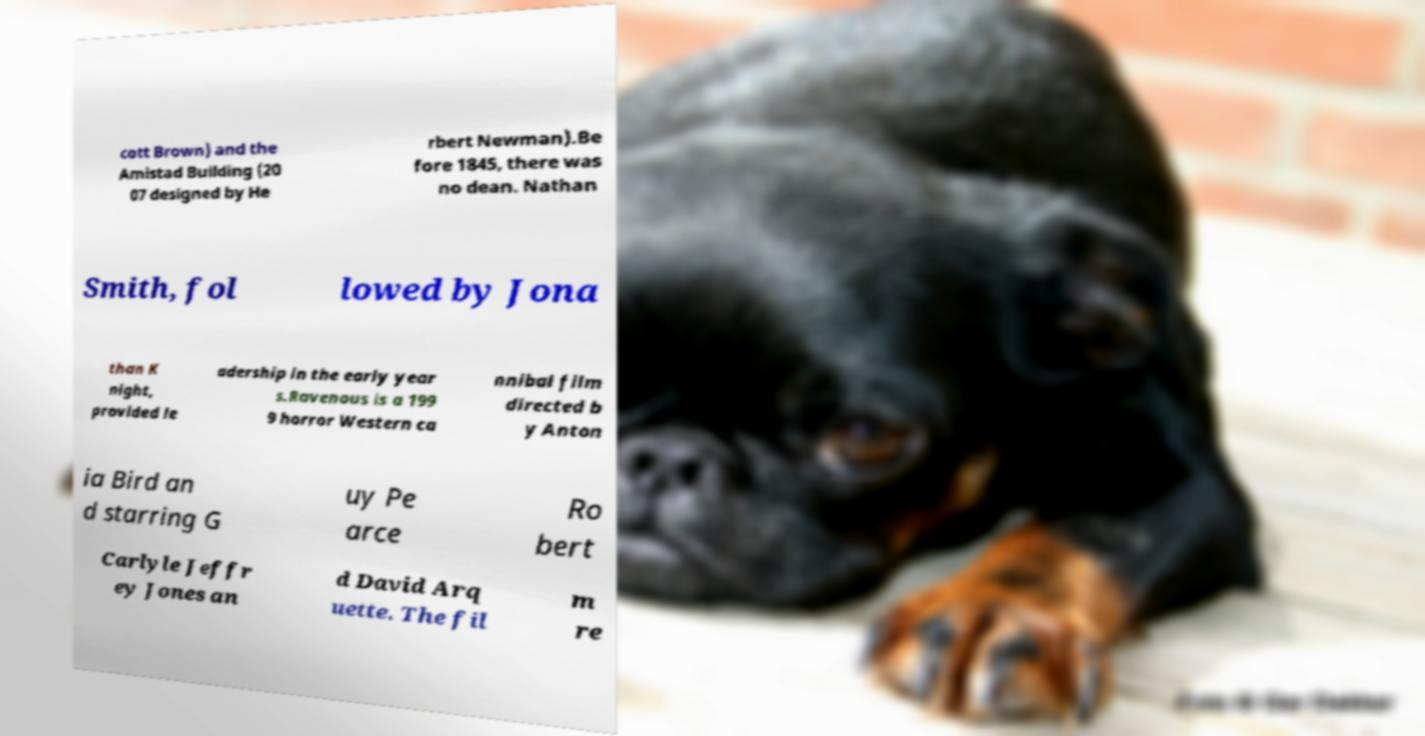Can you read and provide the text displayed in the image?This photo seems to have some interesting text. Can you extract and type it out for me? cott Brown) and the Amistad Building (20 07 designed by He rbert Newman).Be fore 1845, there was no dean. Nathan Smith, fol lowed by Jona than K night, provided le adership in the early year s.Ravenous is a 199 9 horror Western ca nnibal film directed b y Anton ia Bird an d starring G uy Pe arce Ro bert Carlyle Jeffr ey Jones an d David Arq uette. The fil m re 